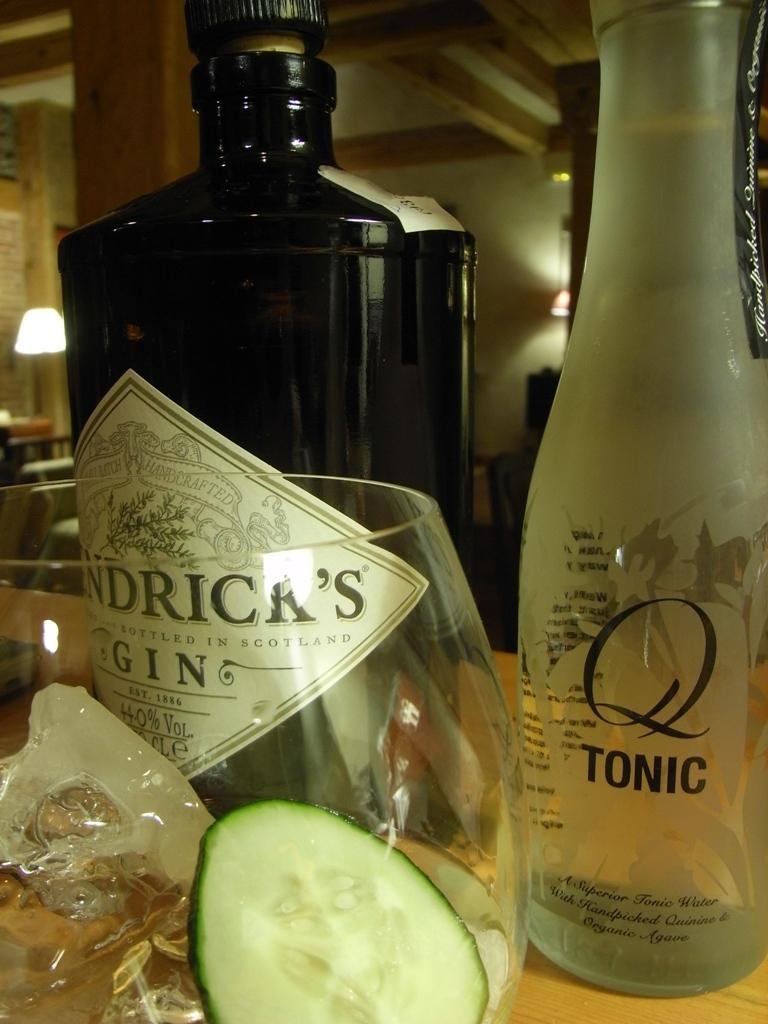Describe this image in one or two sentences. In this picture we can see two bottles and glass with radish pieces in it and in background we can see pillar, light, wall. 